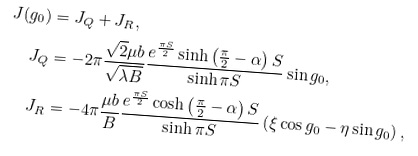Convert formula to latex. <formula><loc_0><loc_0><loc_500><loc_500>J ( g _ { 0 } ) & = J _ { Q } + J _ { R } , \\ J _ { Q } & = - 2 \pi \frac { \sqrt { 2 } \mu b } { \sqrt { \lambda B } } \frac { e ^ { \frac { \pi S } { 2 } } \sinh \left ( \frac { \pi } { 2 } - \alpha \right ) S } { \sinh \pi S } \sin g _ { 0 } , \\ J _ { R } & = - 4 \pi \frac { \mu b } { B } \frac { e ^ { \frac { \pi S } { 2 } } \cosh \left ( \frac { \pi } { 2 } - \alpha \right ) S } { \sinh \pi S } \left ( \xi \cos g _ { 0 } - \eta \sin g _ { 0 } \right ) ,</formula> 